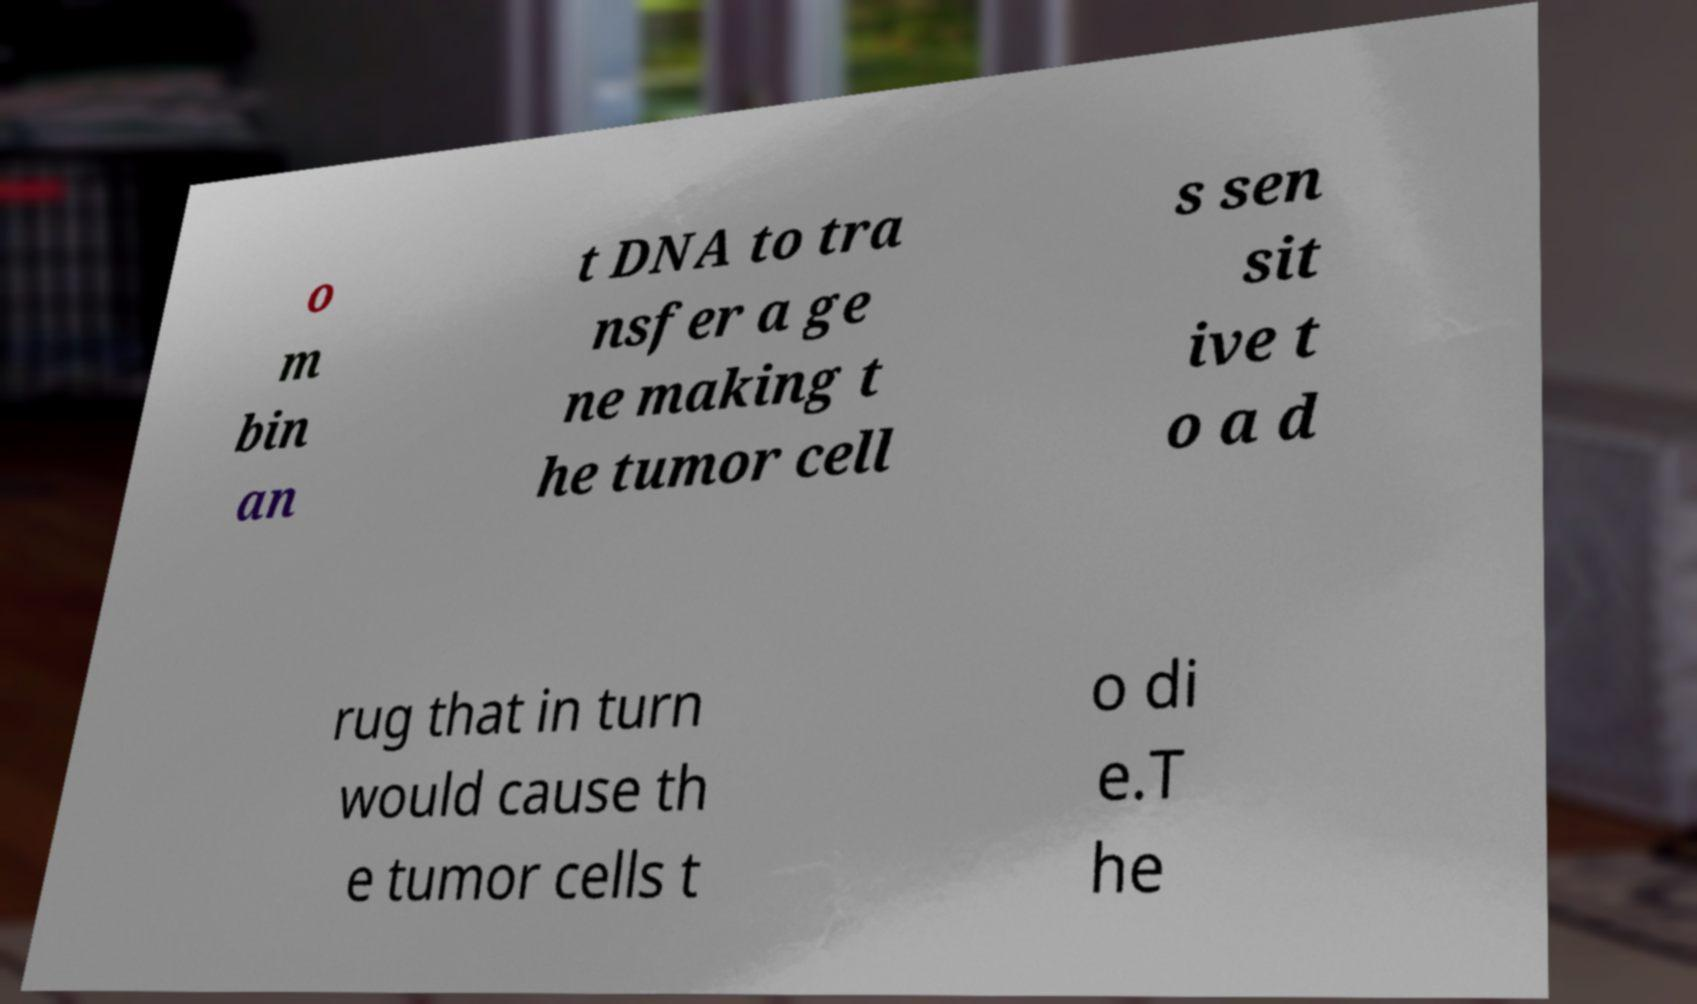For documentation purposes, I need the text within this image transcribed. Could you provide that? o m bin an t DNA to tra nsfer a ge ne making t he tumor cell s sen sit ive t o a d rug that in turn would cause th e tumor cells t o di e.T he 